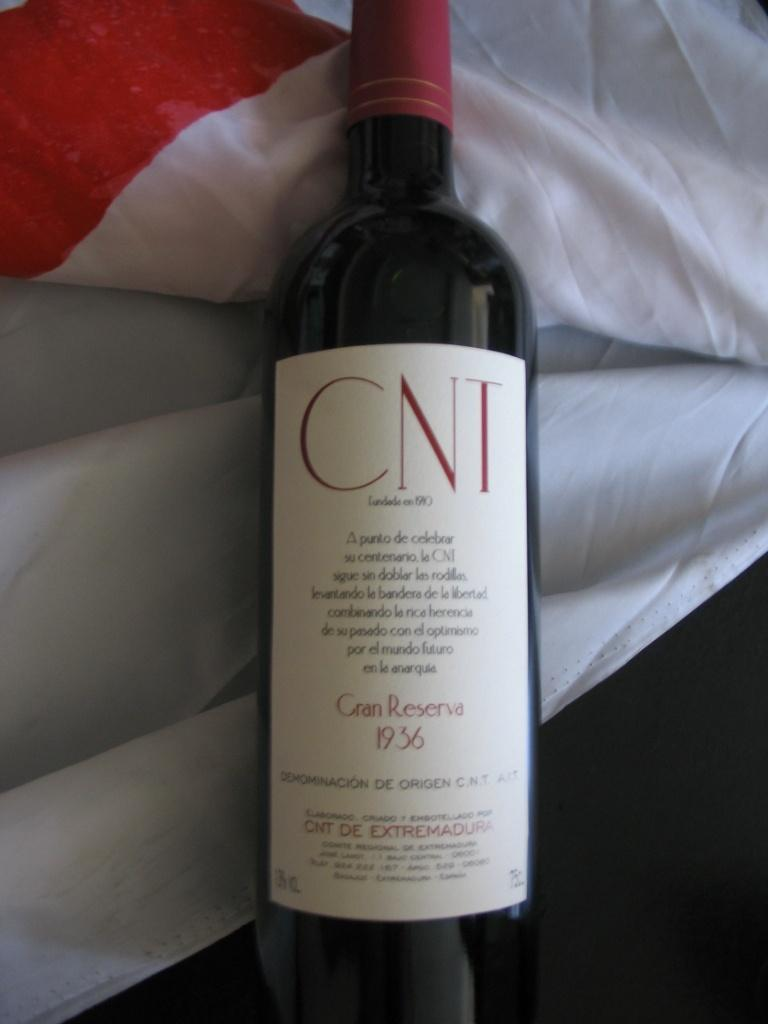Provide a one-sentence caption for the provided image. A bottle of CNT wine from 1936 on top of a white sheet. 